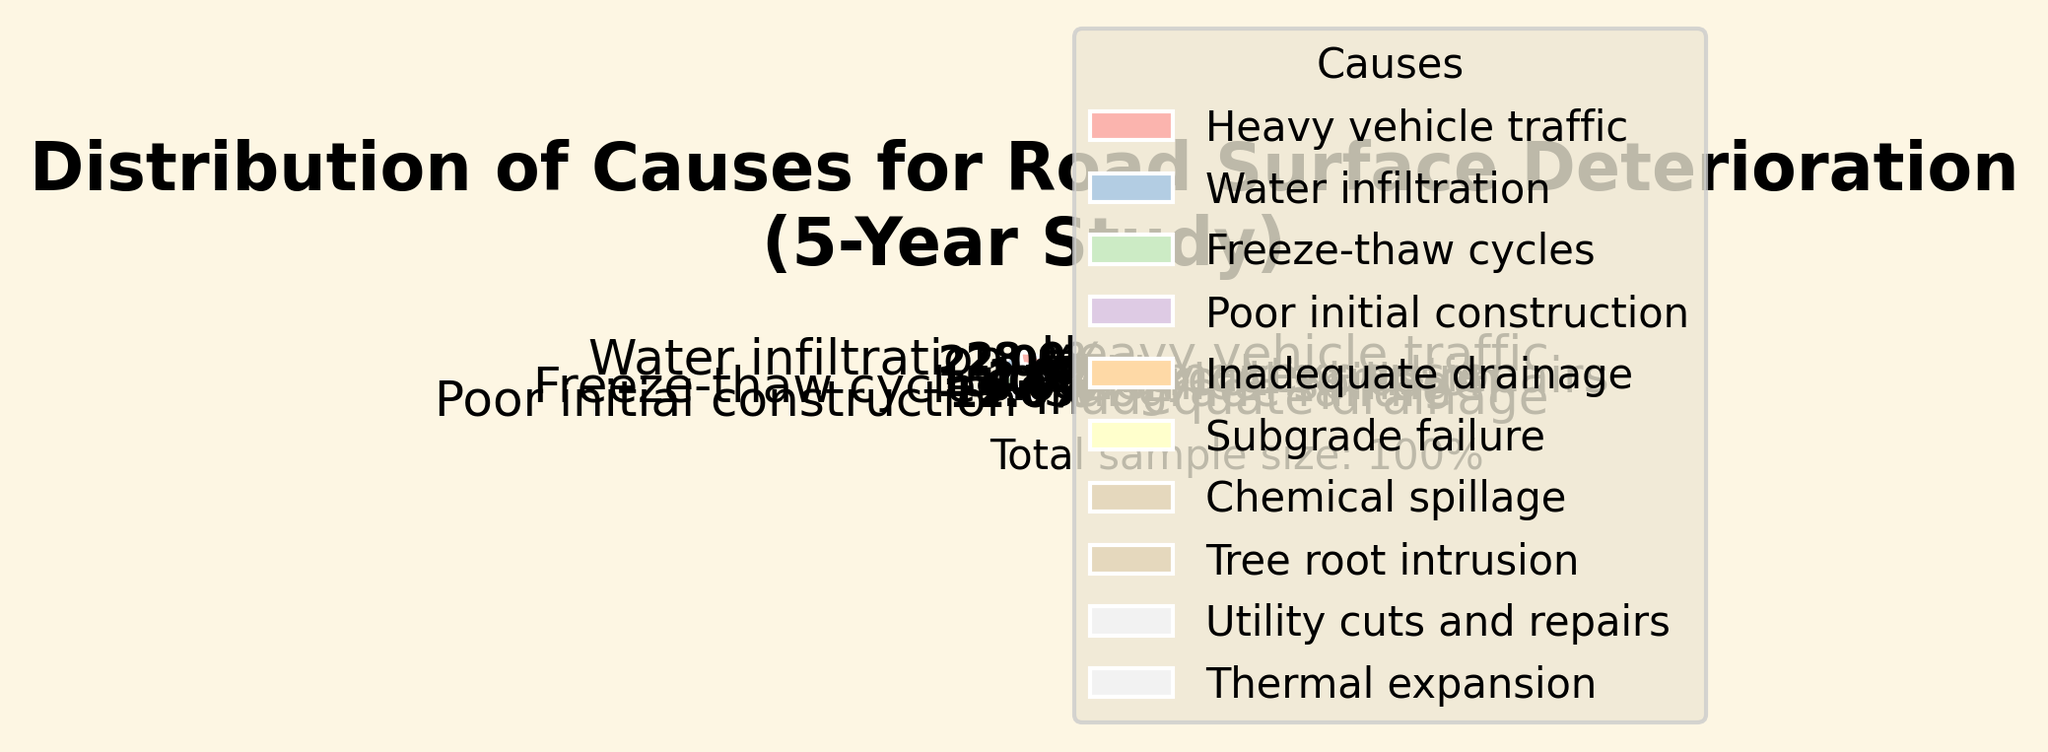What is the most common cause of road surface deterioration according to the study? The pie chart shows different causes contributing to road surface deterioration with their percentages. From the chart, the largest segment is labeled "Heavy vehicle traffic" at 28%.
Answer: Heavy vehicle traffic What is the combined percentage of road surface deterioration caused by Water infiltration and Freeze-thaw cycles? According to the pie chart, Water infiltration accounts for 22% and Freeze-thaw cycles account for 15%. Adding these percentages together gives 22% + 15% = 37%.
Answer: 37% Which cause of road surface deterioration has the smallest contribution? The pie chart shows "Utility cuts and repairs" and "Thermal expansion" as the smallest segments, both contributing 1% each to the road surface deterioration.
Answer: Utility cuts and repairs / Thermal expansion How does the contribution of Poor initial construction compare to Inadequate drainage? The pie chart shows Poor initial construction at 12% and Inadequate drainage at 9%. Comparing these numbers, Poor initial construction has a 3% higher contribution than Inadequate drainage.
Answer: Poor initial construction is 3% higher What's the percentage difference between Heavy vehicle traffic and Subgrade failure? From the pie chart, Heavy vehicle traffic is 28% and Subgrade failure is 6%. The difference is 28% - 6% = 22%.
Answer: 22% What is the total percentage contributed by causes other than Heavy vehicle traffic and Water infiltration? The total percentage is 100%, and Heavy vehicle traffic is 28% while Water infiltration is 22%. The combined percentage of these two causes is 28% + 22% = 50%. Therefore, the percentage contributed by other causes is 100% - 50% = 50%.
Answer: 50% Which has a greater contribution to road surface deterioration: Chemical spillage or Tree root intrusion? The pie chart shows Chemical spillage at 4% and Tree root intrusion at 2%. Therefore, Chemical spillage has a greater contribution.
Answer: Chemical spillage How many causes have a contribution percentage of less than 10%? From the pie chart, the causes with less than 10% contribution are Inadequate drainage (9%), Subgrade failure (6%), Chemical spillage (4%), Tree root intrusion (2%), Utility cuts and repairs (1%), and Thermal expansion (1%). Counting these causes gives us 6 causes.
Answer: 6 